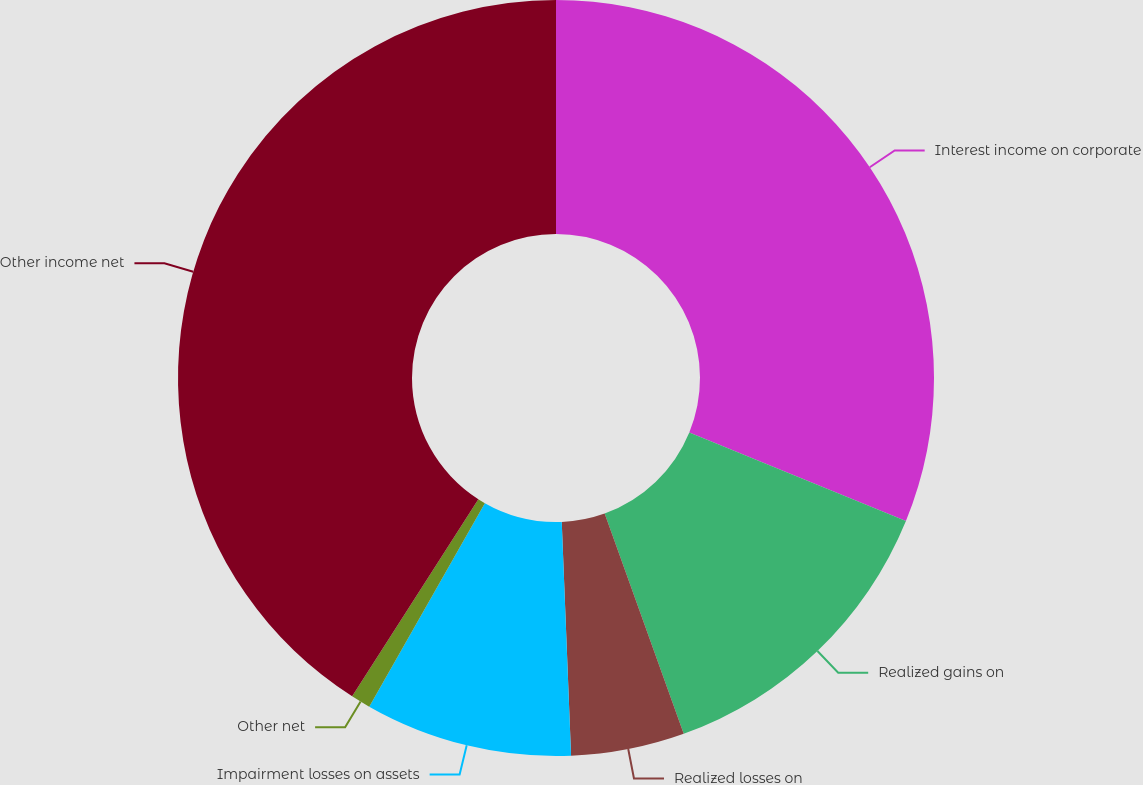<chart> <loc_0><loc_0><loc_500><loc_500><pie_chart><fcel>Interest income on corporate<fcel>Realized gains on<fcel>Realized losses on<fcel>Impairment losses on assets<fcel>Other net<fcel>Other income net<nl><fcel>31.17%<fcel>13.34%<fcel>4.85%<fcel>8.86%<fcel>0.84%<fcel>40.93%<nl></chart> 